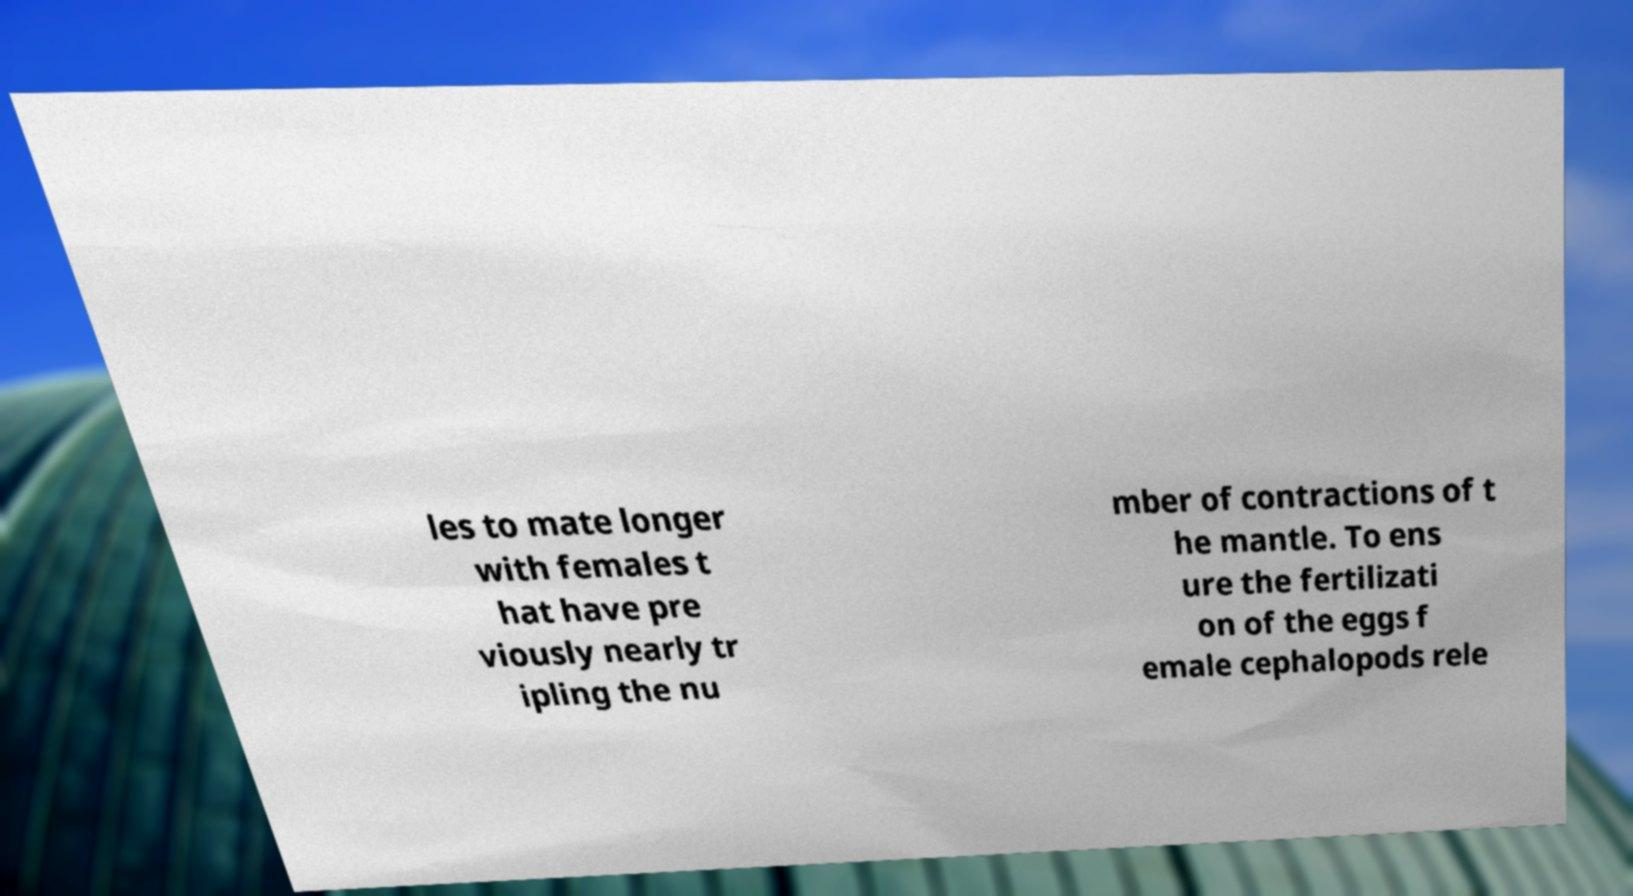Please identify and transcribe the text found in this image. les to mate longer with females t hat have pre viously nearly tr ipling the nu mber of contractions of t he mantle. To ens ure the fertilizati on of the eggs f emale cephalopods rele 